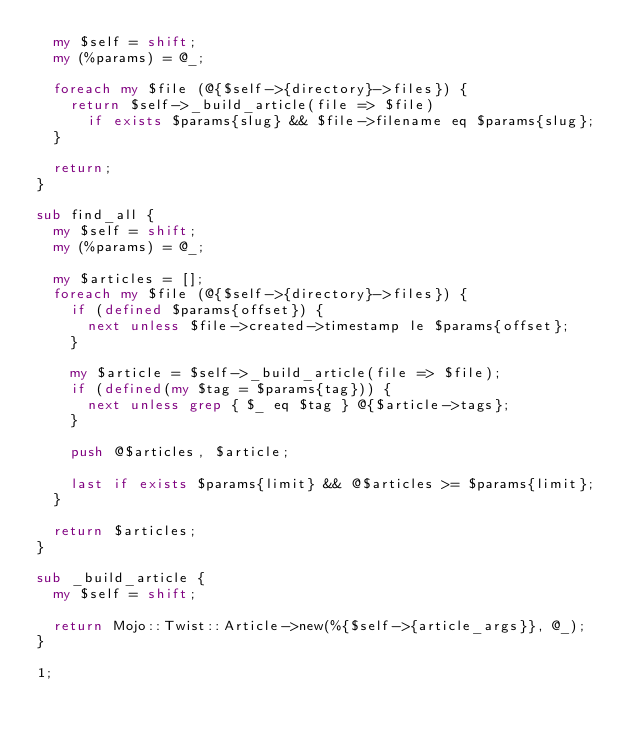<code> <loc_0><loc_0><loc_500><loc_500><_Perl_>  my $self = shift;
  my (%params) = @_;

  foreach my $file (@{$self->{directory}->files}) {
    return $self->_build_article(file => $file)
      if exists $params{slug} && $file->filename eq $params{slug};
  }

  return;
}

sub find_all {
  my $self = shift;
  my (%params) = @_;

  my $articles = [];
  foreach my $file (@{$self->{directory}->files}) {
    if (defined $params{offset}) {
      next unless $file->created->timestamp le $params{offset};
    }

    my $article = $self->_build_article(file => $file);
    if (defined(my $tag = $params{tag})) {
      next unless grep { $_ eq $tag } @{$article->tags};
    }

    push @$articles, $article;

    last if exists $params{limit} && @$articles >= $params{limit};
  }

  return $articles;
}

sub _build_article {
  my $self = shift;

  return Mojo::Twist::Article->new(%{$self->{article_args}}, @_);
}

1;
</code> 